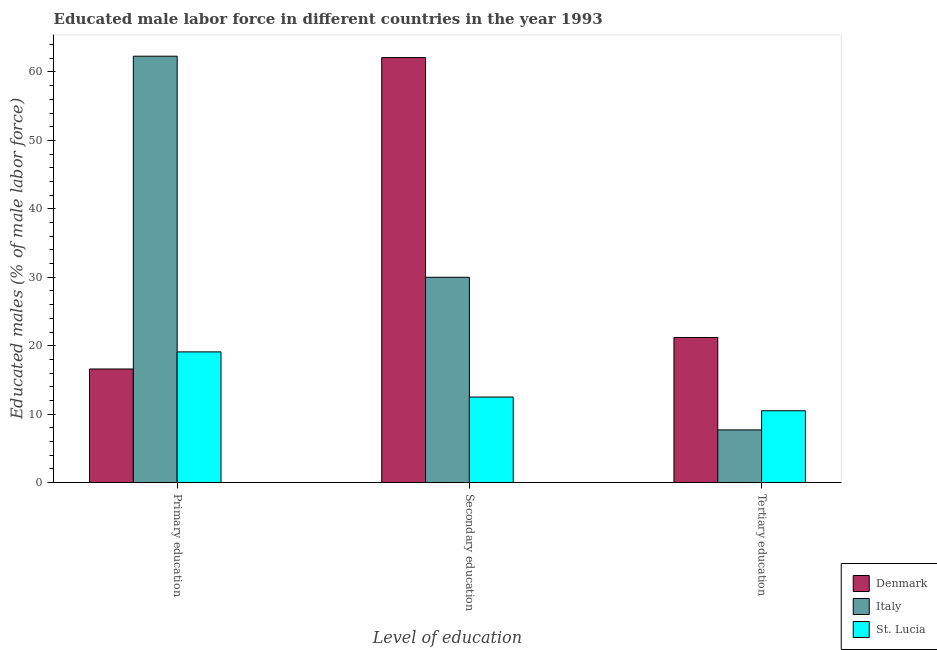How many different coloured bars are there?
Provide a short and direct response. 3. How many groups of bars are there?
Give a very brief answer. 3. Are the number of bars per tick equal to the number of legend labels?
Make the answer very short. Yes. Are the number of bars on each tick of the X-axis equal?
Your answer should be compact. Yes. How many bars are there on the 1st tick from the left?
Ensure brevity in your answer.  3. How many bars are there on the 3rd tick from the right?
Give a very brief answer. 3. What is the percentage of male labor force who received primary education in Italy?
Keep it short and to the point. 62.3. Across all countries, what is the maximum percentage of male labor force who received secondary education?
Your answer should be compact. 62.1. Across all countries, what is the minimum percentage of male labor force who received primary education?
Make the answer very short. 16.6. In which country was the percentage of male labor force who received secondary education maximum?
Provide a short and direct response. Denmark. In which country was the percentage of male labor force who received secondary education minimum?
Offer a terse response. St. Lucia. What is the total percentage of male labor force who received tertiary education in the graph?
Offer a terse response. 39.4. What is the difference between the percentage of male labor force who received tertiary education in St. Lucia and that in Italy?
Keep it short and to the point. 2.8. What is the difference between the percentage of male labor force who received tertiary education in Italy and the percentage of male labor force who received primary education in St. Lucia?
Give a very brief answer. -11.4. What is the average percentage of male labor force who received tertiary education per country?
Ensure brevity in your answer.  13.13. What is the difference between the percentage of male labor force who received primary education and percentage of male labor force who received tertiary education in St. Lucia?
Make the answer very short. 8.6. In how many countries, is the percentage of male labor force who received primary education greater than 38 %?
Keep it short and to the point. 1. What is the ratio of the percentage of male labor force who received primary education in Denmark to that in St. Lucia?
Provide a short and direct response. 0.87. Is the difference between the percentage of male labor force who received tertiary education in St. Lucia and Denmark greater than the difference between the percentage of male labor force who received primary education in St. Lucia and Denmark?
Keep it short and to the point. No. What is the difference between the highest and the second highest percentage of male labor force who received secondary education?
Your answer should be very brief. 32.1. What is the difference between the highest and the lowest percentage of male labor force who received primary education?
Offer a terse response. 45.7. In how many countries, is the percentage of male labor force who received primary education greater than the average percentage of male labor force who received primary education taken over all countries?
Give a very brief answer. 1. Is the sum of the percentage of male labor force who received tertiary education in Italy and St. Lucia greater than the maximum percentage of male labor force who received secondary education across all countries?
Offer a terse response. No. What does the 1st bar from the left in Primary education represents?
Your response must be concise. Denmark. What does the 1st bar from the right in Secondary education represents?
Provide a succinct answer. St. Lucia. Is it the case that in every country, the sum of the percentage of male labor force who received primary education and percentage of male labor force who received secondary education is greater than the percentage of male labor force who received tertiary education?
Your response must be concise. Yes. How many countries are there in the graph?
Ensure brevity in your answer.  3. What is the difference between two consecutive major ticks on the Y-axis?
Offer a very short reply. 10. Does the graph contain any zero values?
Keep it short and to the point. No. How are the legend labels stacked?
Make the answer very short. Vertical. What is the title of the graph?
Give a very brief answer. Educated male labor force in different countries in the year 1993. What is the label or title of the X-axis?
Provide a succinct answer. Level of education. What is the label or title of the Y-axis?
Keep it short and to the point. Educated males (% of male labor force). What is the Educated males (% of male labor force) of Denmark in Primary education?
Provide a succinct answer. 16.6. What is the Educated males (% of male labor force) of Italy in Primary education?
Ensure brevity in your answer.  62.3. What is the Educated males (% of male labor force) in St. Lucia in Primary education?
Ensure brevity in your answer.  19.1. What is the Educated males (% of male labor force) in Denmark in Secondary education?
Ensure brevity in your answer.  62.1. What is the Educated males (% of male labor force) in Denmark in Tertiary education?
Make the answer very short. 21.2. What is the Educated males (% of male labor force) in Italy in Tertiary education?
Offer a very short reply. 7.7. What is the Educated males (% of male labor force) of St. Lucia in Tertiary education?
Offer a terse response. 10.5. Across all Level of education, what is the maximum Educated males (% of male labor force) in Denmark?
Your answer should be compact. 62.1. Across all Level of education, what is the maximum Educated males (% of male labor force) in Italy?
Ensure brevity in your answer.  62.3. Across all Level of education, what is the maximum Educated males (% of male labor force) of St. Lucia?
Provide a short and direct response. 19.1. Across all Level of education, what is the minimum Educated males (% of male labor force) in Denmark?
Keep it short and to the point. 16.6. Across all Level of education, what is the minimum Educated males (% of male labor force) in Italy?
Provide a short and direct response. 7.7. What is the total Educated males (% of male labor force) of Denmark in the graph?
Your response must be concise. 99.9. What is the total Educated males (% of male labor force) of St. Lucia in the graph?
Provide a succinct answer. 42.1. What is the difference between the Educated males (% of male labor force) in Denmark in Primary education and that in Secondary education?
Your answer should be very brief. -45.5. What is the difference between the Educated males (% of male labor force) in Italy in Primary education and that in Secondary education?
Your response must be concise. 32.3. What is the difference between the Educated males (% of male labor force) of St. Lucia in Primary education and that in Secondary education?
Ensure brevity in your answer.  6.6. What is the difference between the Educated males (% of male labor force) in Italy in Primary education and that in Tertiary education?
Keep it short and to the point. 54.6. What is the difference between the Educated males (% of male labor force) of St. Lucia in Primary education and that in Tertiary education?
Provide a short and direct response. 8.6. What is the difference between the Educated males (% of male labor force) in Denmark in Secondary education and that in Tertiary education?
Ensure brevity in your answer.  40.9. What is the difference between the Educated males (% of male labor force) in Italy in Secondary education and that in Tertiary education?
Your answer should be very brief. 22.3. What is the difference between the Educated males (% of male labor force) of Denmark in Primary education and the Educated males (% of male labor force) of St. Lucia in Secondary education?
Offer a terse response. 4.1. What is the difference between the Educated males (% of male labor force) of Italy in Primary education and the Educated males (% of male labor force) of St. Lucia in Secondary education?
Give a very brief answer. 49.8. What is the difference between the Educated males (% of male labor force) of Italy in Primary education and the Educated males (% of male labor force) of St. Lucia in Tertiary education?
Your answer should be very brief. 51.8. What is the difference between the Educated males (% of male labor force) of Denmark in Secondary education and the Educated males (% of male labor force) of Italy in Tertiary education?
Keep it short and to the point. 54.4. What is the difference between the Educated males (% of male labor force) in Denmark in Secondary education and the Educated males (% of male labor force) in St. Lucia in Tertiary education?
Offer a very short reply. 51.6. What is the average Educated males (% of male labor force) of Denmark per Level of education?
Your answer should be very brief. 33.3. What is the average Educated males (% of male labor force) of Italy per Level of education?
Your answer should be compact. 33.33. What is the average Educated males (% of male labor force) of St. Lucia per Level of education?
Offer a very short reply. 14.03. What is the difference between the Educated males (% of male labor force) of Denmark and Educated males (% of male labor force) of Italy in Primary education?
Ensure brevity in your answer.  -45.7. What is the difference between the Educated males (% of male labor force) in Denmark and Educated males (% of male labor force) in St. Lucia in Primary education?
Provide a short and direct response. -2.5. What is the difference between the Educated males (% of male labor force) of Italy and Educated males (% of male labor force) of St. Lucia in Primary education?
Your answer should be very brief. 43.2. What is the difference between the Educated males (% of male labor force) of Denmark and Educated males (% of male labor force) of Italy in Secondary education?
Your answer should be compact. 32.1. What is the difference between the Educated males (% of male labor force) in Denmark and Educated males (% of male labor force) in St. Lucia in Secondary education?
Your answer should be compact. 49.6. What is the difference between the Educated males (% of male labor force) of Denmark and Educated males (% of male labor force) of Italy in Tertiary education?
Give a very brief answer. 13.5. What is the difference between the Educated males (% of male labor force) in Italy and Educated males (% of male labor force) in St. Lucia in Tertiary education?
Offer a very short reply. -2.8. What is the ratio of the Educated males (% of male labor force) in Denmark in Primary education to that in Secondary education?
Keep it short and to the point. 0.27. What is the ratio of the Educated males (% of male labor force) in Italy in Primary education to that in Secondary education?
Provide a succinct answer. 2.08. What is the ratio of the Educated males (% of male labor force) in St. Lucia in Primary education to that in Secondary education?
Provide a succinct answer. 1.53. What is the ratio of the Educated males (% of male labor force) in Denmark in Primary education to that in Tertiary education?
Your answer should be very brief. 0.78. What is the ratio of the Educated males (% of male labor force) of Italy in Primary education to that in Tertiary education?
Keep it short and to the point. 8.09. What is the ratio of the Educated males (% of male labor force) of St. Lucia in Primary education to that in Tertiary education?
Make the answer very short. 1.82. What is the ratio of the Educated males (% of male labor force) in Denmark in Secondary education to that in Tertiary education?
Offer a very short reply. 2.93. What is the ratio of the Educated males (% of male labor force) of Italy in Secondary education to that in Tertiary education?
Provide a succinct answer. 3.9. What is the ratio of the Educated males (% of male labor force) of St. Lucia in Secondary education to that in Tertiary education?
Your answer should be very brief. 1.19. What is the difference between the highest and the second highest Educated males (% of male labor force) of Denmark?
Your answer should be compact. 40.9. What is the difference between the highest and the second highest Educated males (% of male labor force) in Italy?
Your answer should be compact. 32.3. What is the difference between the highest and the lowest Educated males (% of male labor force) of Denmark?
Your answer should be compact. 45.5. What is the difference between the highest and the lowest Educated males (% of male labor force) of Italy?
Make the answer very short. 54.6. What is the difference between the highest and the lowest Educated males (% of male labor force) in St. Lucia?
Provide a succinct answer. 8.6. 